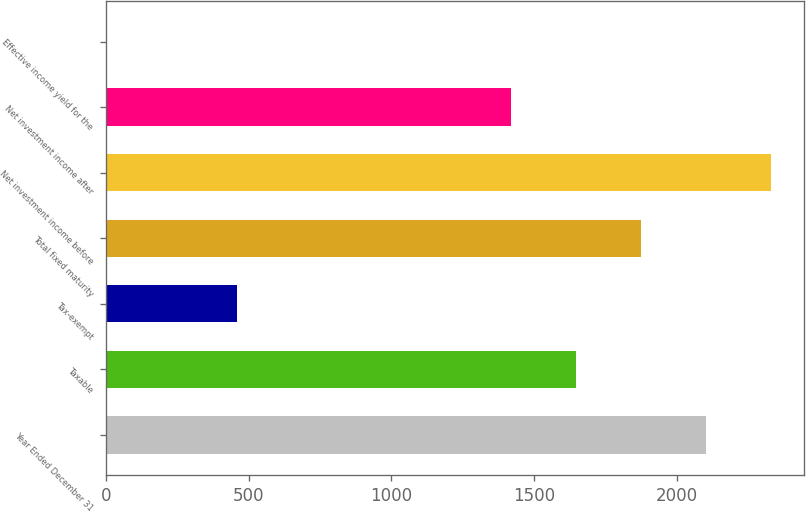<chart> <loc_0><loc_0><loc_500><loc_500><bar_chart><fcel>Year Ended December 31<fcel>Taxable<fcel>Tax-exempt<fcel>Total fixed maturity<fcel>Net investment income before<fcel>Net investment income after<fcel>Effective income yield for the<nl><fcel>2101.55<fcel>1645.85<fcel>459.2<fcel>1873.7<fcel>2329.4<fcel>1418<fcel>3.5<nl></chart> 